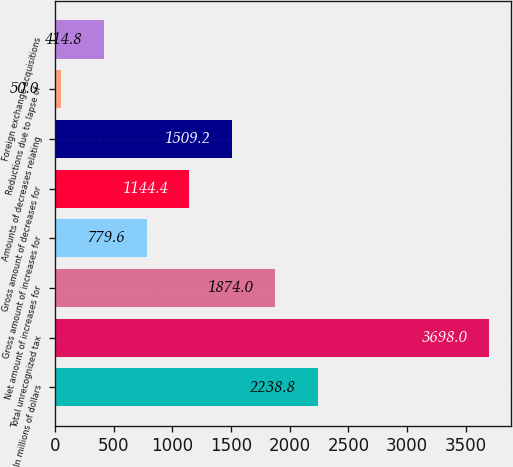<chart> <loc_0><loc_0><loc_500><loc_500><bar_chart><fcel>In millions of dollars<fcel>Total unrecognized tax<fcel>Net amount of increases for<fcel>Gross amount of increases for<fcel>Gross amount of decreases for<fcel>Amounts of decreases relating<fcel>Reductions due to lapse of<fcel>Foreign exchange acquisitions<nl><fcel>2238.8<fcel>3698<fcel>1874<fcel>779.6<fcel>1144.4<fcel>1509.2<fcel>50<fcel>414.8<nl></chart> 